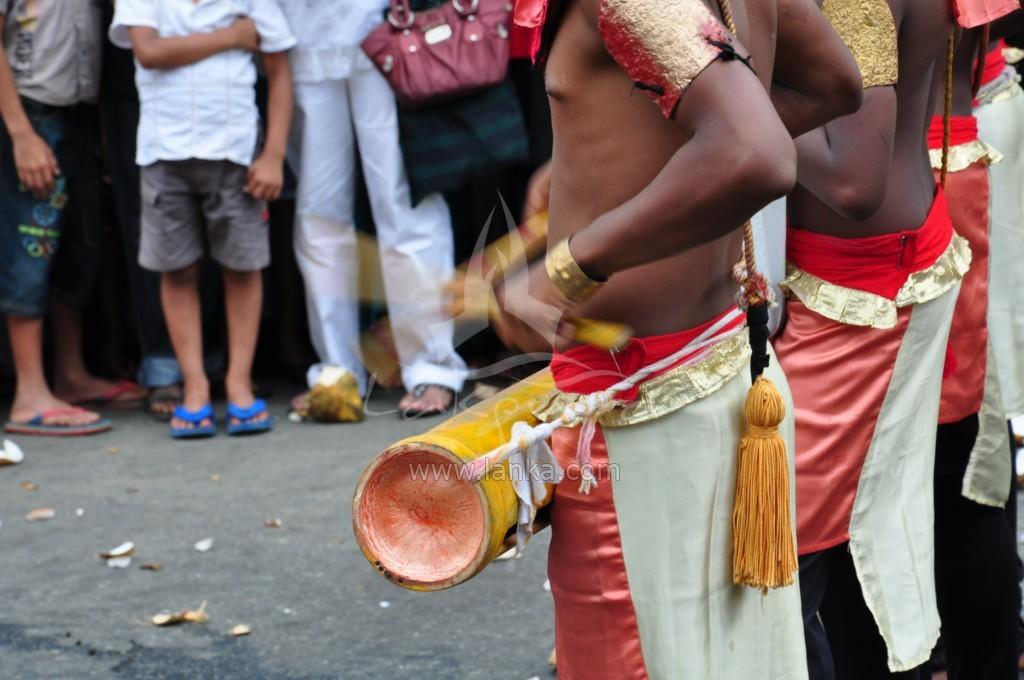How many people are in the image? There is a group of people in the image, but the exact number is not specified. Where are the people located in the image? The people are standing on the road. What type of chess piece is the tallest in the image? There is no chess piece present in the image; it features a group of people standing on the road. 